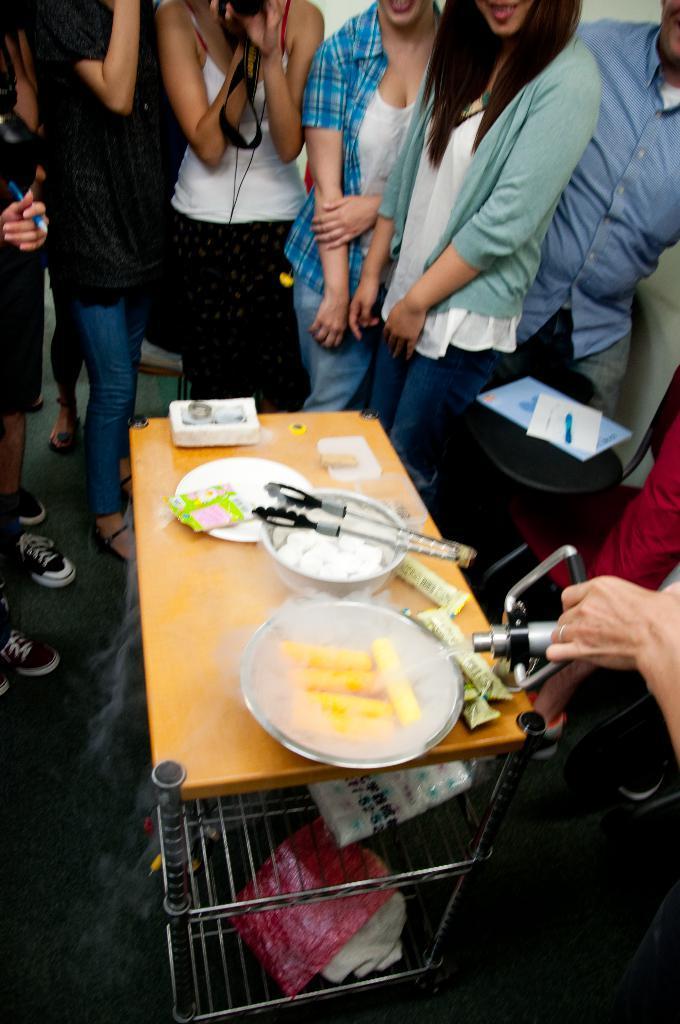Can you describe this image briefly? Here we can see some persons are standing on the floor. This is table. On the table there is a bowl, plate, and some food. 